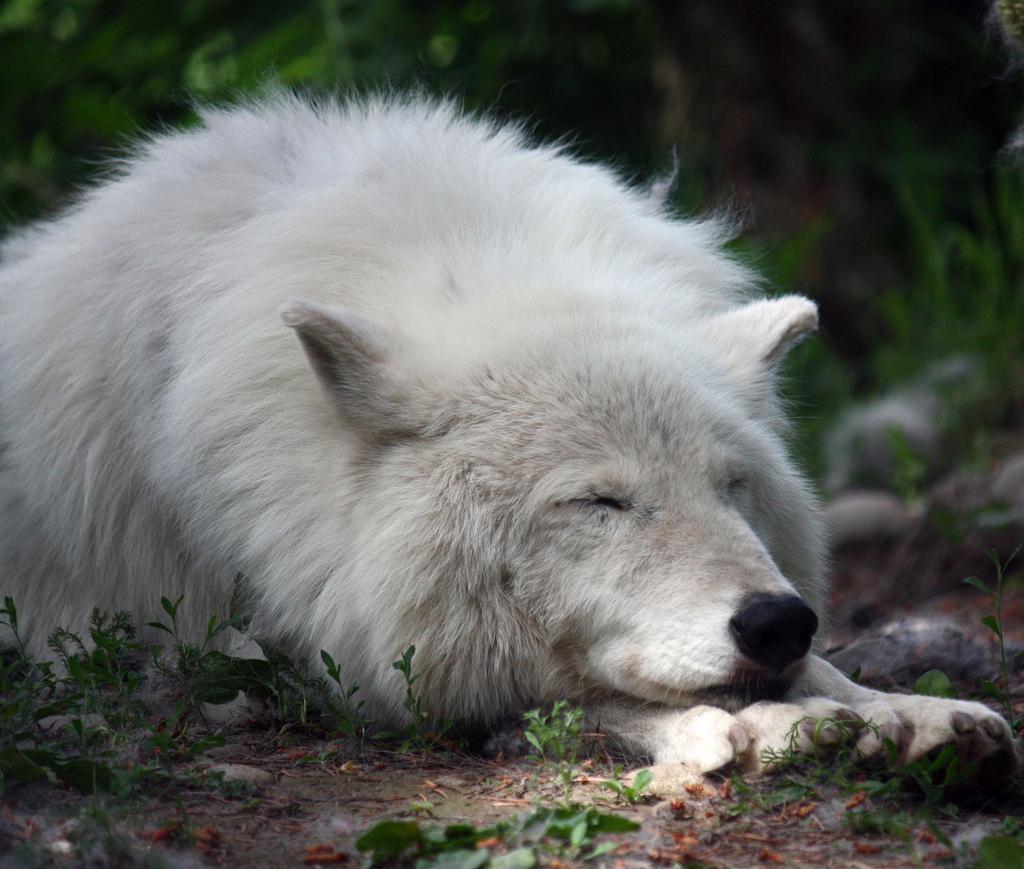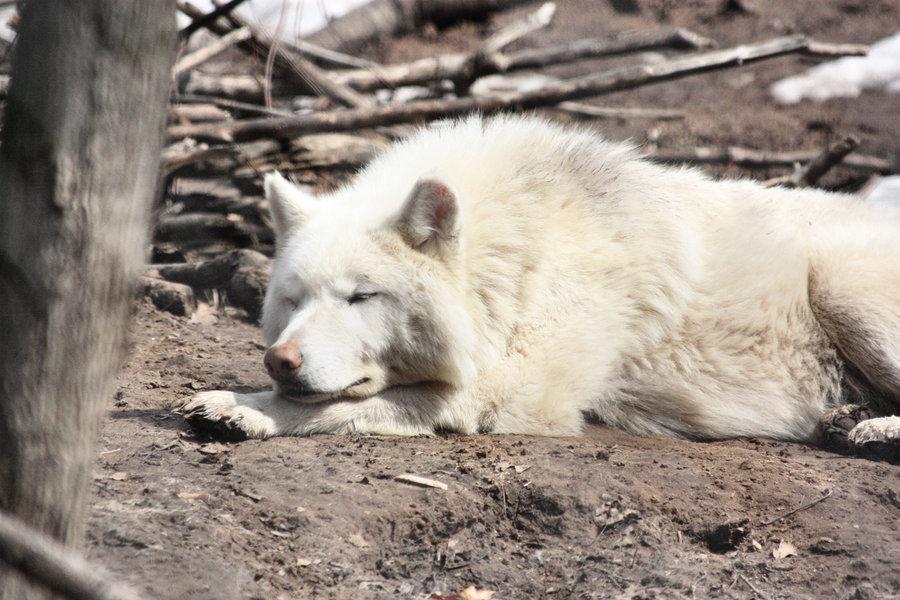The first image is the image on the left, the second image is the image on the right. Analyze the images presented: Is the assertion "Each image shows a reclining white dog with fully closed eyes, and the dogs in the left and right images look similar in terms of size, coloring, breed and ear position." valid? Answer yes or no. Yes. The first image is the image on the left, the second image is the image on the right. Examine the images to the left and right. Is the description "At least one white wolf has its eyes open." accurate? Answer yes or no. No. 